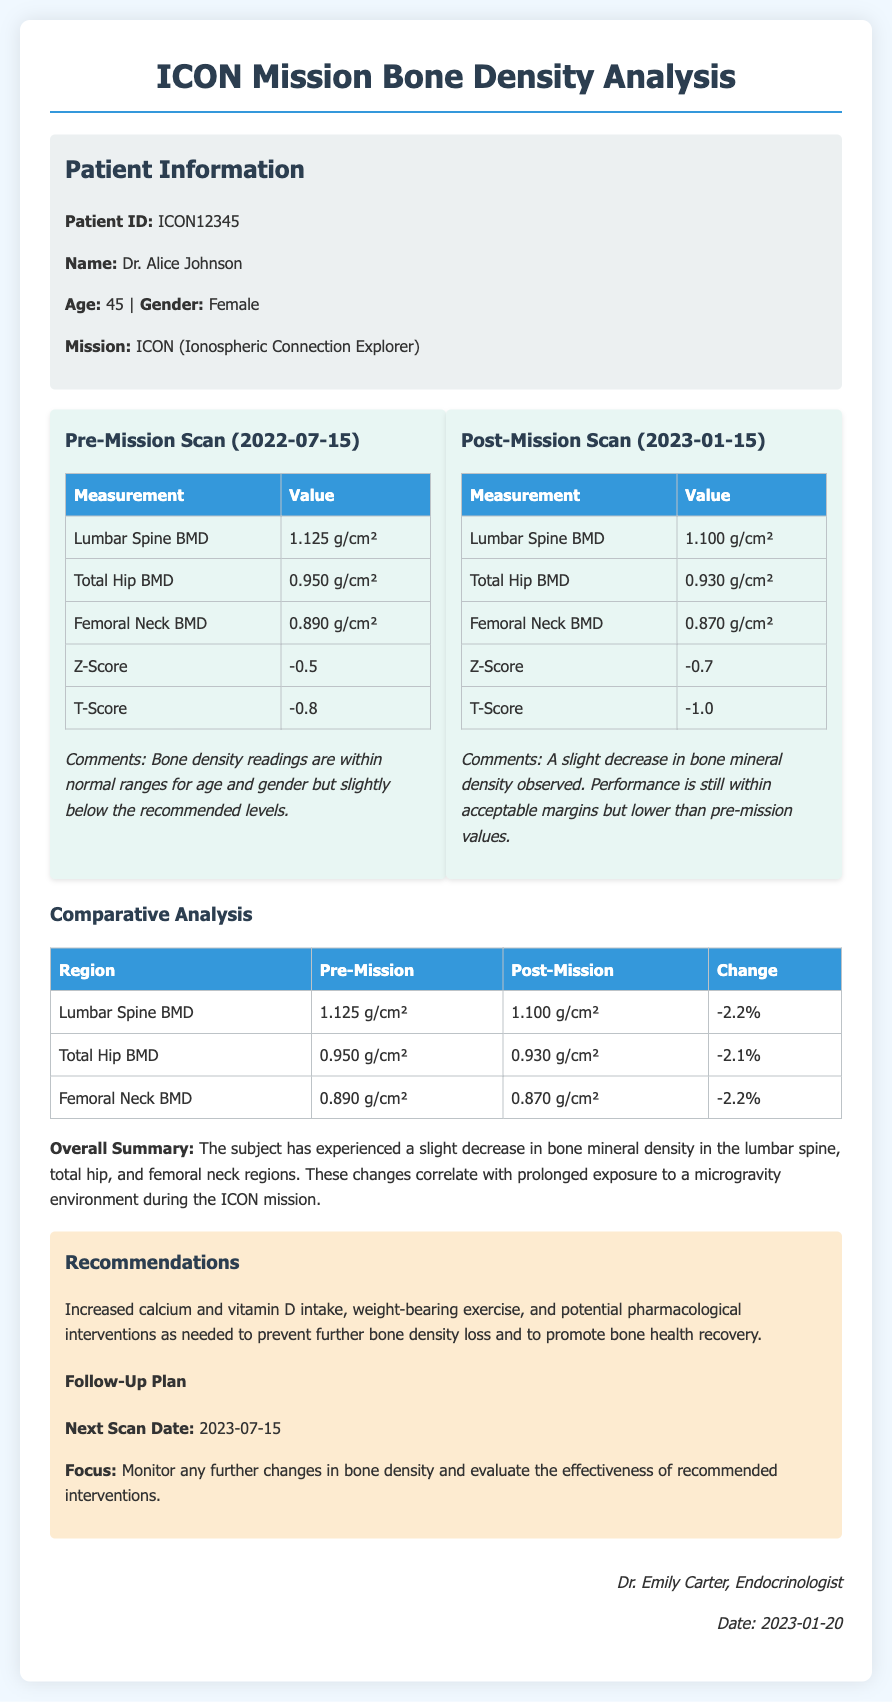what is the patient ID? The patient ID is specified in the Patient Information section of the document, which is ICON12345.
Answer: ICON12345 what is the age of Dr. Alice Johnson? The age of Dr. Alice Johnson is provided in the Patient Information section as 45.
Answer: 45 what is the lumbar spine BMD pre-mission? The pre-mission lumbar spine BMD is stated in the Pre-Mission Scan section as 1.125 g/cm².
Answer: 1.125 g/cm² what is the percentage change in femoral neck BMD post-mission? The percentage change in femoral neck BMD can be calculated from the Comparative Analysis table, which shows a change of -2.2%.
Answer: -2.2% what are the recommended interventions for bone density loss? The recommended interventions to prevent further bone density loss are listed in the Recommendations section of the document.
Answer: Increased calcium and vitamin D intake, weight-bearing exercise, and potential pharmacological interventions what is the mission name associated with Dr. Alice Johnson? The mission name is found in the Patient Information section as ICON (Ionospheric Connection Explorer).
Answer: ICON (Ionospheric Connection Explorer) what is the date of the next scan? The next scan date is indicated in the Follow-Up Plan section of the Recommendations, which is 2023-07-15.
Answer: 2023-07-15 who authored this medical record? The name of the author is included at the end of the document in the signature section.
Answer: Dr. Emily Carter what was the Z-Score for the post-mission scan? The Z-Score for the post-mission scan is listed in the Post-Mission Scan section as -0.7.
Answer: -0.7 